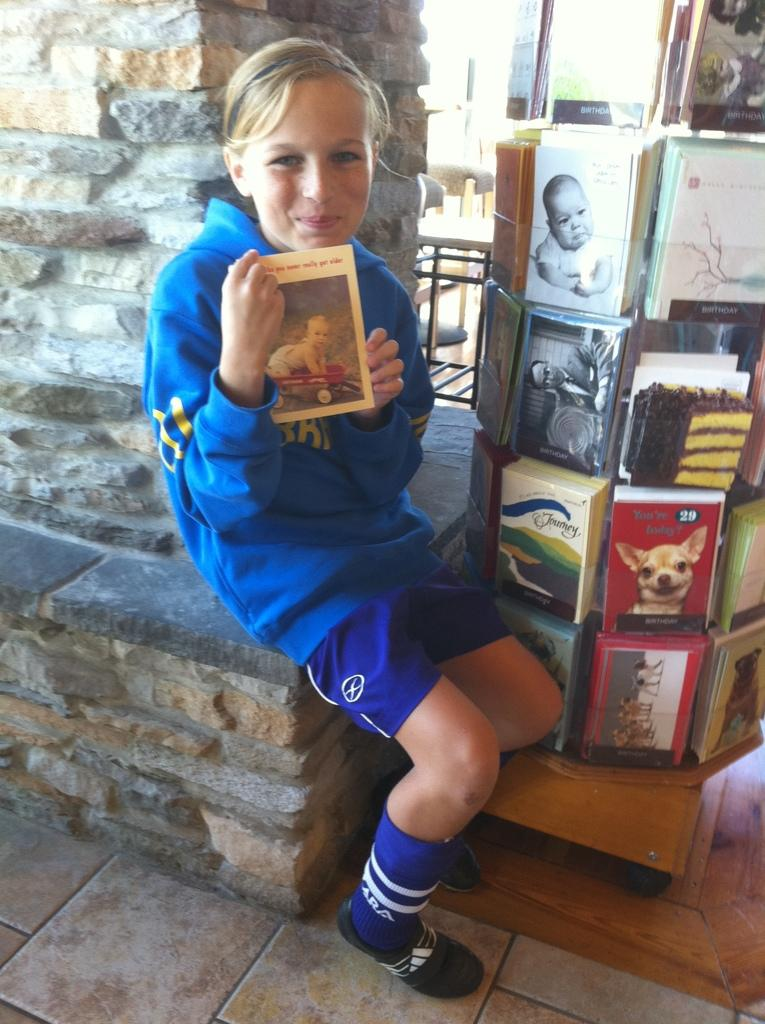Who is the main subject in the image? There is a girl in the image. What is the girl doing in the image? The girl is sitting. What is the girl holding in her hand? The girl is holding a book in her hand. What can be seen near the girl in the image? There is a stand in the image, and there are books on the stand. What is visible in the background of the image? There is a pillar in the background of the image. What type of shirt is the girl wearing in the image? The provided facts do not mention the girl's shirt, so we cannot determine the type of shirt she is wearing. What stone was discovered by the girl's reading session? There is no mention of a stone or any discovery in the image, so we cannot answer this question. 